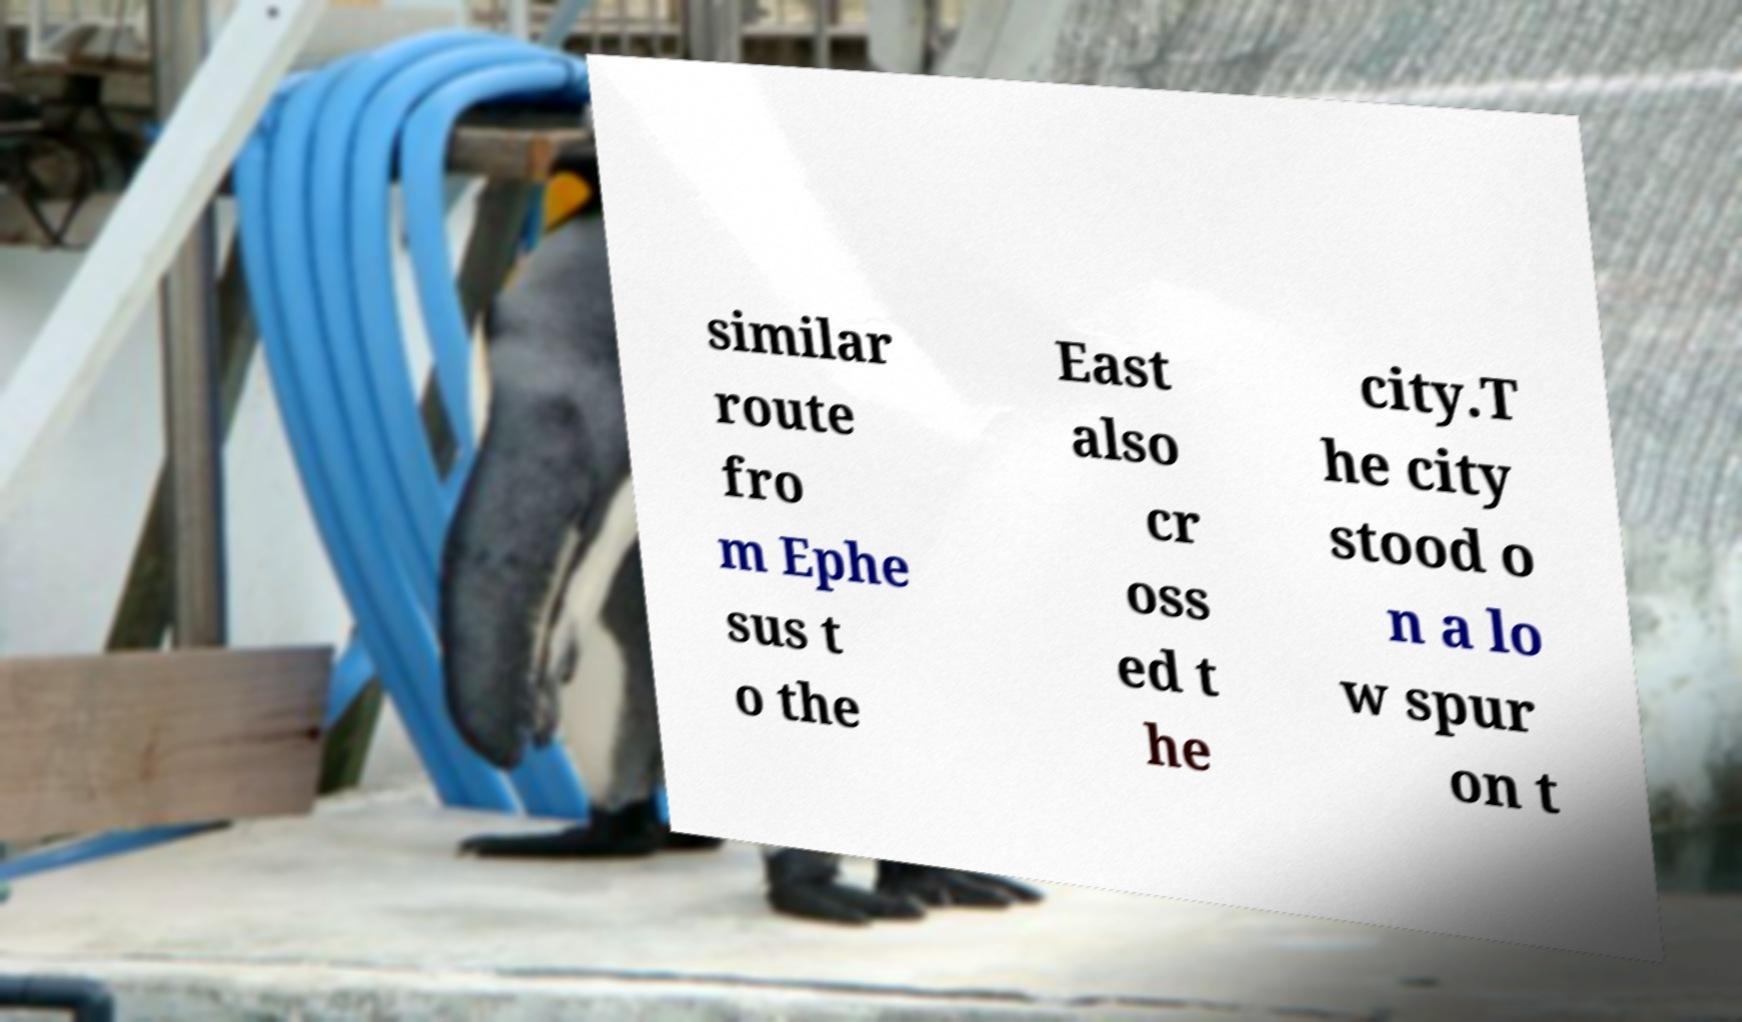I need the written content from this picture converted into text. Can you do that? similar route fro m Ephe sus t o the East also cr oss ed t he city.T he city stood o n a lo w spur on t 